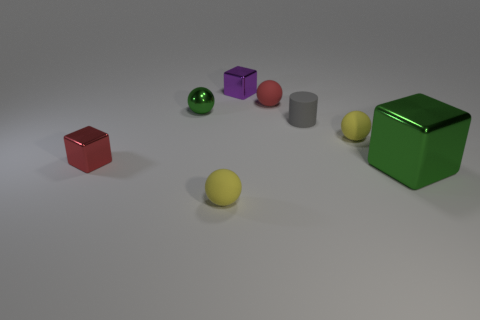Add 1 gray cylinders. How many objects exist? 9 Subtract all tiny cubes. How many cubes are left? 1 Subtract 2 balls. How many balls are left? 2 Subtract all red blocks. How many blocks are left? 2 Subtract all red cylinders. Subtract all green cubes. How many cylinders are left? 1 Subtract all brown balls. How many red cylinders are left? 0 Subtract all blue metallic blocks. Subtract all matte things. How many objects are left? 4 Add 1 tiny metal spheres. How many tiny metal spheres are left? 2 Add 1 tiny cyan metallic balls. How many tiny cyan metallic balls exist? 1 Subtract 1 yellow balls. How many objects are left? 7 